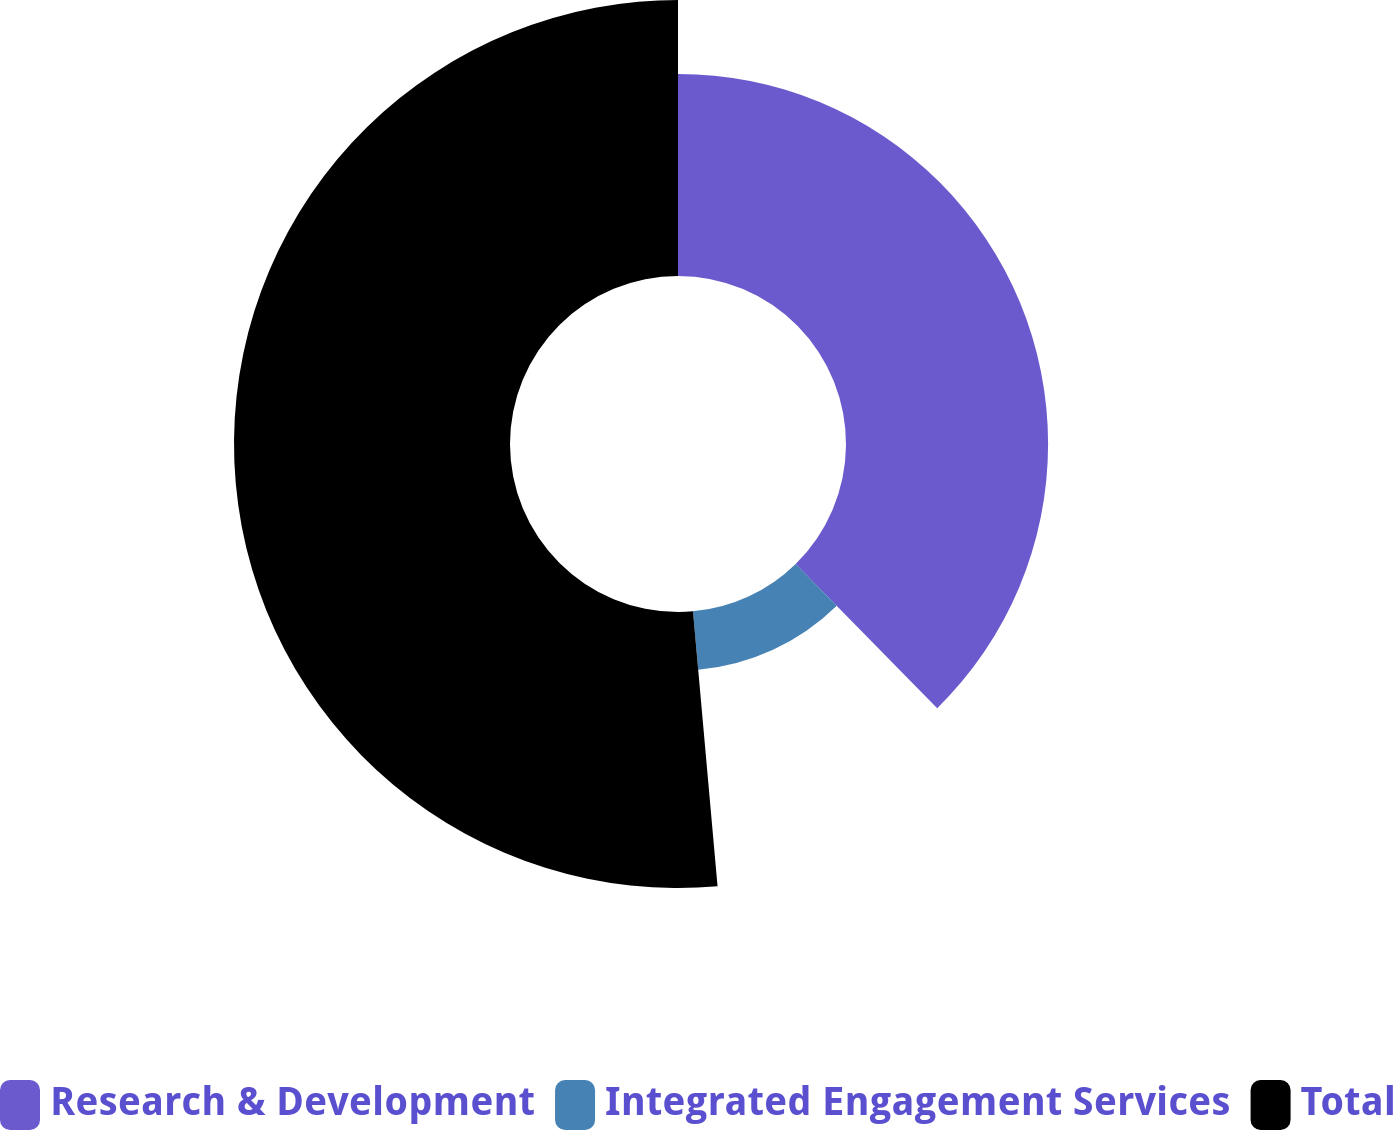Convert chart. <chart><loc_0><loc_0><loc_500><loc_500><pie_chart><fcel>Research & Development<fcel>Integrated Engagement Services<fcel>Total<nl><fcel>37.65%<fcel>10.93%<fcel>51.42%<nl></chart> 